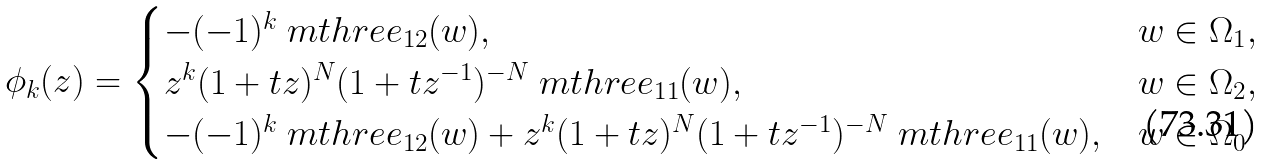Convert formula to latex. <formula><loc_0><loc_0><loc_500><loc_500>\phi _ { k } ( z ) = \begin{cases} - ( - 1 ) ^ { k } \ m t h r e e _ { 1 2 } ( w ) , \quad & w \in \Omega _ { 1 } , \\ z ^ { k } ( 1 + t z ) ^ { N } ( 1 + t z ^ { - 1 } ) ^ { - N } \ m t h r e e _ { 1 1 } ( w ) , \quad & w \in \Omega _ { 2 } , \\ - ( - 1 ) ^ { k } \ m t h r e e _ { 1 2 } ( w ) + z ^ { k } ( 1 + t z ) ^ { N } ( 1 + t z ^ { - 1 } ) ^ { - N } \ m t h r e e _ { 1 1 } ( w ) , & w \in \Omega _ { 0 } \end{cases}</formula> 